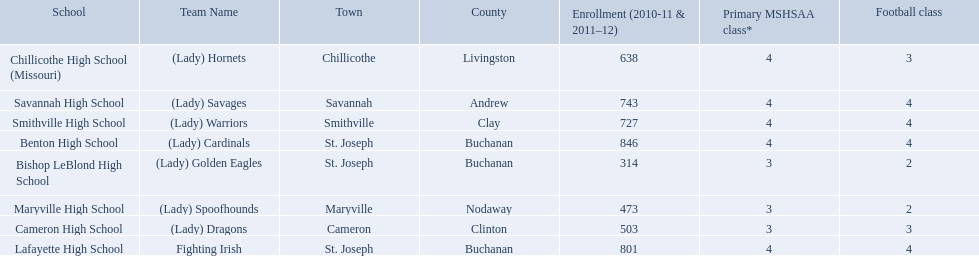What school in midland empire conference has 846 students enrolled? Benton High School. What school has 314 students enrolled? Bishop LeBlond High School. What school had 638 students enrolled? Chillicothe High School (Missouri). 